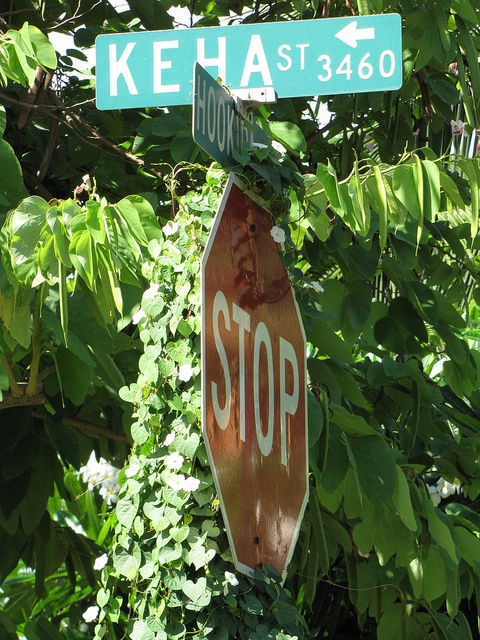Describe the objects in this image and their specific colors. I can see a stop sign in black, maroon, and darkgray tones in this image. 